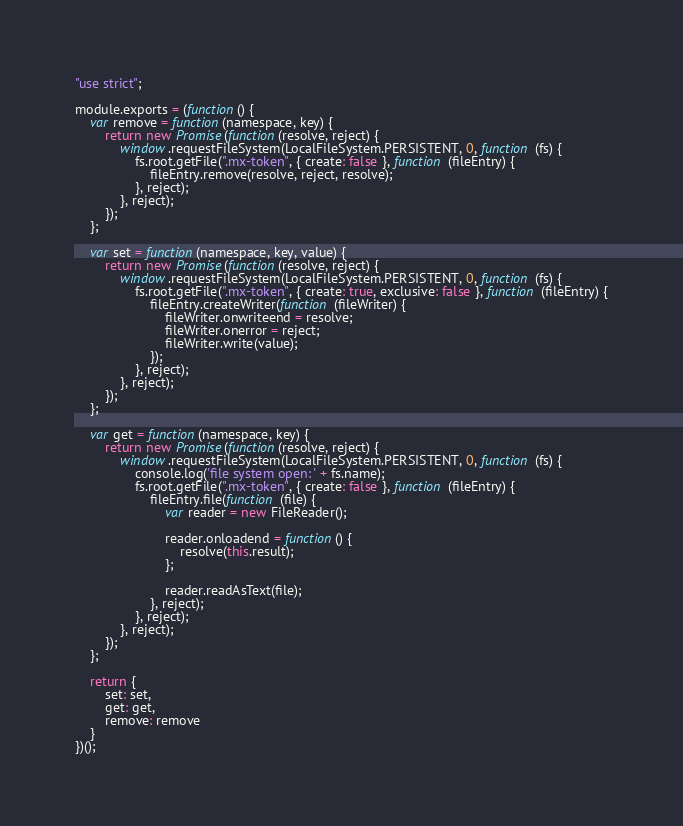<code> <loc_0><loc_0><loc_500><loc_500><_JavaScript_>"use strict";

module.exports = (function() {
    var remove = function(namespace, key) {
        return new Promise(function(resolve, reject) {
            window.requestFileSystem(LocalFileSystem.PERSISTENT, 0, function (fs) {
                fs.root.getFile(".mx-token", { create: false }, function (fileEntry) {
                    fileEntry.remove(resolve, reject, resolve);
                }, reject);
            }, reject);
        });
    };

    var set = function(namespace, key, value) {
        return new Promise(function(resolve, reject) {
            window.requestFileSystem(LocalFileSystem.PERSISTENT, 0, function (fs) {
                fs.root.getFile(".mx-token", { create: true, exclusive: false }, function (fileEntry) {
                    fileEntry.createWriter(function (fileWriter) {
                        fileWriter.onwriteend = resolve;
                        fileWriter.onerror = reject;
                        fileWriter.write(value);
                    });
                }, reject);
            }, reject);
        });
    };

    var get = function(namespace, key) {
        return new Promise(function(resolve, reject) {
            window.requestFileSystem(LocalFileSystem.PERSISTENT, 0, function (fs) {
                console.log('file system open: ' + fs.name);
                fs.root.getFile(".mx-token", { create: false }, function (fileEntry) {
                    fileEntry.file(function (file) {
                        var reader = new FileReader();

                        reader.onloadend = function() {
                            resolve(this.result);
                        };

                        reader.readAsText(file);
                    }, reject);
                }, reject);
            }, reject);
        });
    };

    return {
        set: set,
        get: get,
        remove: remove
    }
})();
</code> 